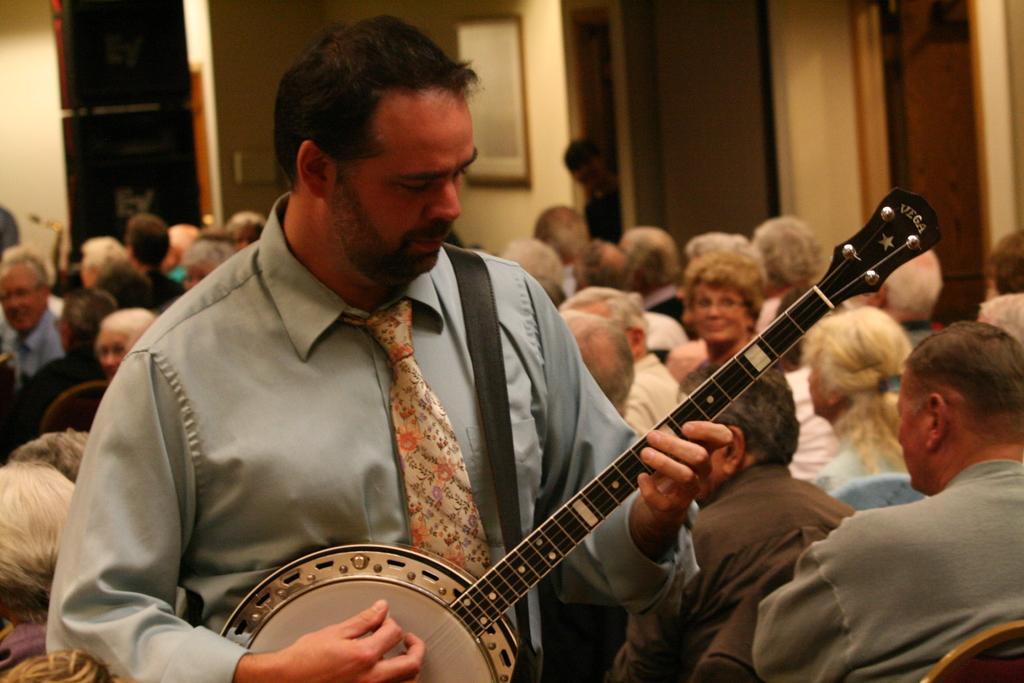How would you summarize this image in a sentence or two? This picture is taken in a room. There is a man in the center, he is wearing a blue shirt, colorful tie and he is playing a guitar. Towards the right corner there is a man wearing a grey shirt and he is sitting on chair. In the background there are group of people sitting on chair. 